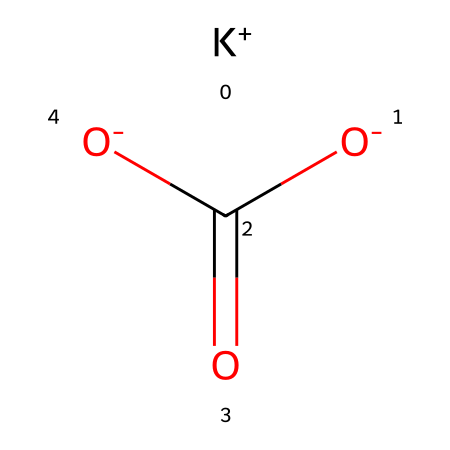how many oxygen atoms are in potassium bicarbonate? The chemical structure contains two oxygen atoms in the carboxylate group (C(=O)[O-]), which indicates that there are a total of two oxygen atoms present.
Answer: 2 what type of ion is represented by the notation [K+]? The notation [K+] indicates a potassium ion with a single positive charge. This signifies that it has lost one electron compared to the neutral potassium atom.
Answer: cation how many hydrogen atoms are present in potassium bicarbonate? The chemical structure does not explicitly show any hydrogen atoms. However, in bicarbonate (HCO3-), there is one hydrogen atom attached to the carbon. Therefore, there is one hydrogen atom in potassium bicarbonate.
Answer: 1 what type of reaction would potassium bicarbonate undergo when dissolved in water? Potassium bicarbonate will undergo dissociation in water, breaking into its constituent ions: K+ and HCO3-. This is a characteristic behavior of ionic compounds when they dissolve.
Answer: dissociation what is the overall charge of the potassium bicarbonate molecule? The overall charge is neutral, as the potassium ion carries a +1 charge and the bicarbonate ion carries a -1 charge, canceling each other out.
Answer: neutral how does potassium bicarbonate contribute to electrolyte balance in the body? Potassium bicarbonate contributes by providing potassium ions, which are essential for maintaining fluid balance, muscle function, and nerve signaling. This replenishing action is crucial for athletes during intense activities.
Answer: potassium ions 